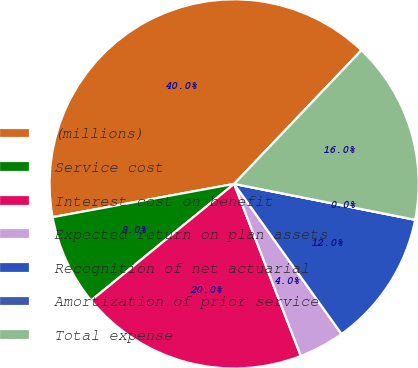<chart> <loc_0><loc_0><loc_500><loc_500><pie_chart><fcel>(millions)<fcel>Service cost<fcel>Interest cost on benefit<fcel>Expected return on plan assets<fcel>Recognition of net actuarial<fcel>Amortization of prior service<fcel>Total expense<nl><fcel>40.0%<fcel>8.0%<fcel>20.0%<fcel>4.0%<fcel>12.0%<fcel>0.0%<fcel>16.0%<nl></chart> 